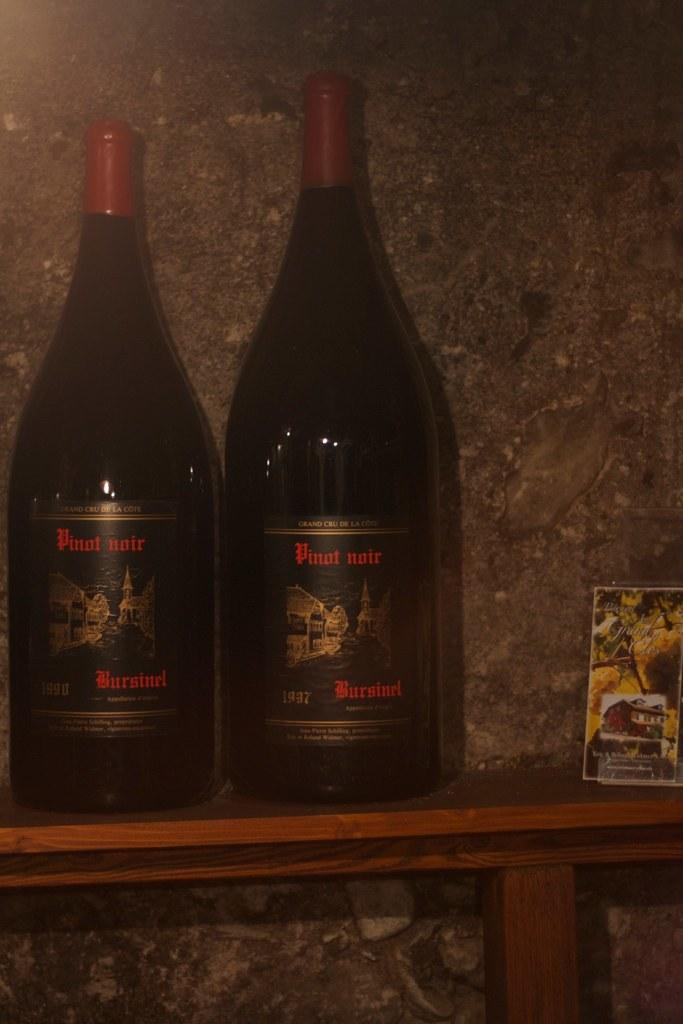<image>
Give a short and clear explanation of the subsequent image. two bottle of pinot noir on a shelf, both of which have red caps. 